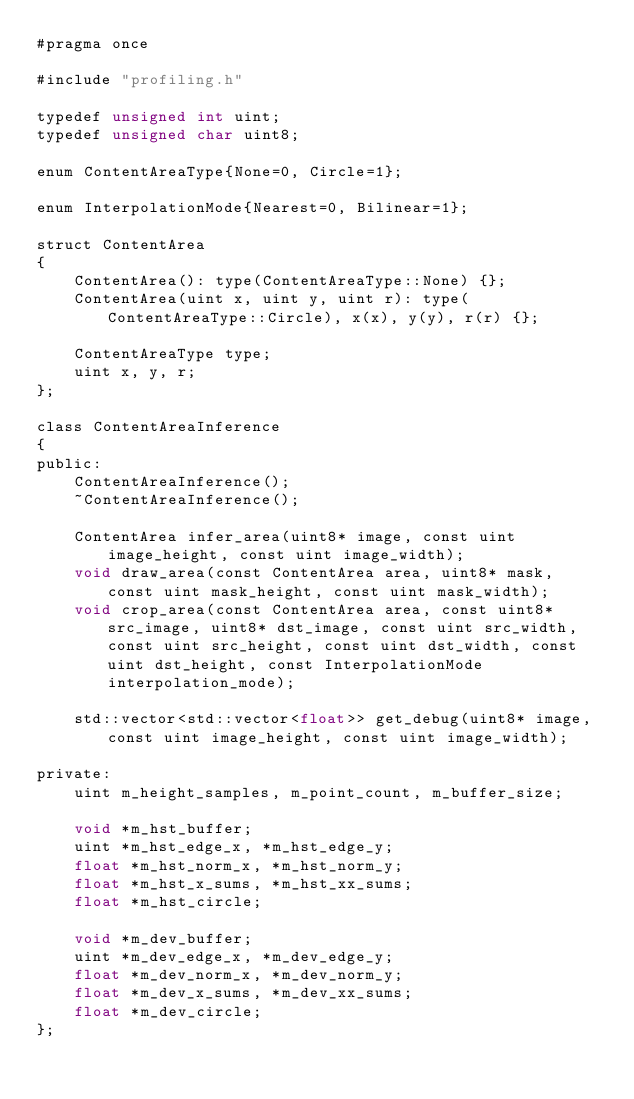Convert code to text. <code><loc_0><loc_0><loc_500><loc_500><_Cuda_>#pragma once

#include "profiling.h"

typedef unsigned int uint;
typedef unsigned char uint8;

enum ContentAreaType{None=0, Circle=1};

enum InterpolationMode{Nearest=0, Bilinear=1};

struct ContentArea
{   
    ContentArea(): type(ContentAreaType::None) {};
    ContentArea(uint x, uint y, uint r): type(ContentAreaType::Circle), x(x), y(y), r(r) {};
    
    ContentAreaType type;
    uint x, y, r;
};

class ContentAreaInference
{
public:
    ContentAreaInference();
    ~ContentAreaInference();

    ContentArea infer_area(uint8* image, const uint image_height, const uint image_width);
    void draw_area(const ContentArea area, uint8* mask, const uint mask_height, const uint mask_width);
    void crop_area(const ContentArea area, const uint8* src_image, uint8* dst_image, const uint src_width, const uint src_height, const uint dst_width, const uint dst_height, const InterpolationMode interpolation_mode);

    std::vector<std::vector<float>> get_debug(uint8* image, const uint image_height, const uint image_width);

private:
    uint m_height_samples, m_point_count, m_buffer_size;

    void *m_hst_buffer;
    uint *m_hst_edge_x, *m_hst_edge_y;
    float *m_hst_norm_x, *m_hst_norm_y;
    float *m_hst_x_sums, *m_hst_xx_sums;
    float *m_hst_circle;
    
    void *m_dev_buffer;
    uint *m_dev_edge_x, *m_dev_edge_y;
    float *m_dev_norm_x, *m_dev_norm_y;
    float *m_dev_x_sums, *m_dev_xx_sums;
    float *m_dev_circle;
};
</code> 